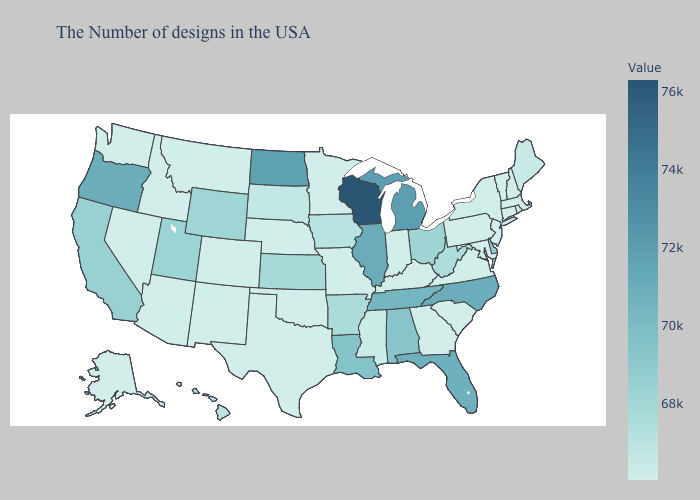Does New Hampshire have the highest value in the Northeast?
Answer briefly. No. Does Maine have the highest value in the USA?
Give a very brief answer. No. Does West Virginia have the highest value in the South?
Concise answer only. No. Does Oregon have the highest value in the West?
Keep it brief. Yes. Which states have the lowest value in the USA?
Keep it brief. Massachusetts, New Hampshire, Vermont, Connecticut, New Jersey, Maryland, Pennsylvania, Virginia, South Carolina, Georgia, Kentucky, Indiana, Missouri, Minnesota, Nebraska, Oklahoma, Texas, Colorado, New Mexico, Montana, Arizona, Idaho, Nevada, Washington, Alaska. Among the states that border California , which have the lowest value?
Quick response, please. Arizona, Nevada. 